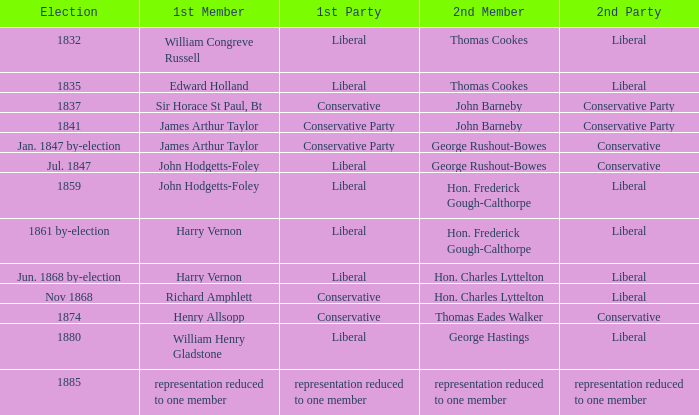What was the 1st Party when the 1st Member was William Congreve Russell? Liberal. 